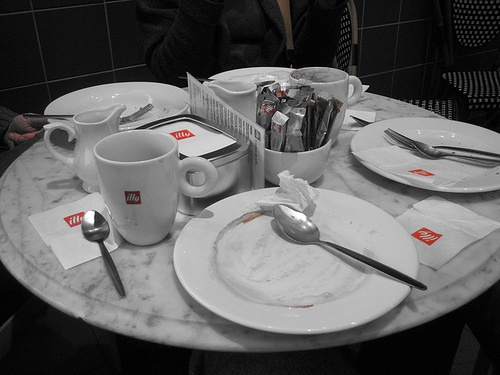Describe the objects in this image and their specific colors. I can see dining table in darkgray, black, gray, and lightgray tones, people in black, maroon, and gray tones, cup in black, gray, and lightgray tones, chair in black and darkgray tones, and bowl in black, gray, and maroon tones in this image. 